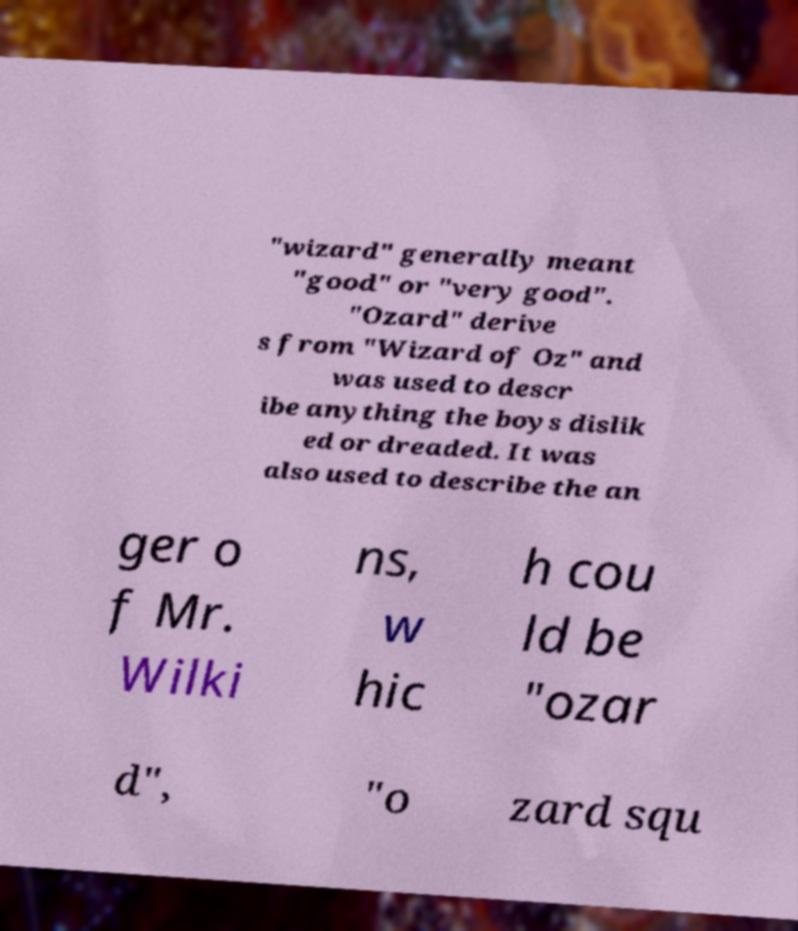Can you accurately transcribe the text from the provided image for me? "wizard" generally meant "good" or "very good". "Ozard" derive s from "Wizard of Oz" and was used to descr ibe anything the boys dislik ed or dreaded. It was also used to describe the an ger o f Mr. Wilki ns, w hic h cou ld be "ozar d", "o zard squ 